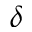Convert formula to latex. <formula><loc_0><loc_0><loc_500><loc_500>\delta</formula> 